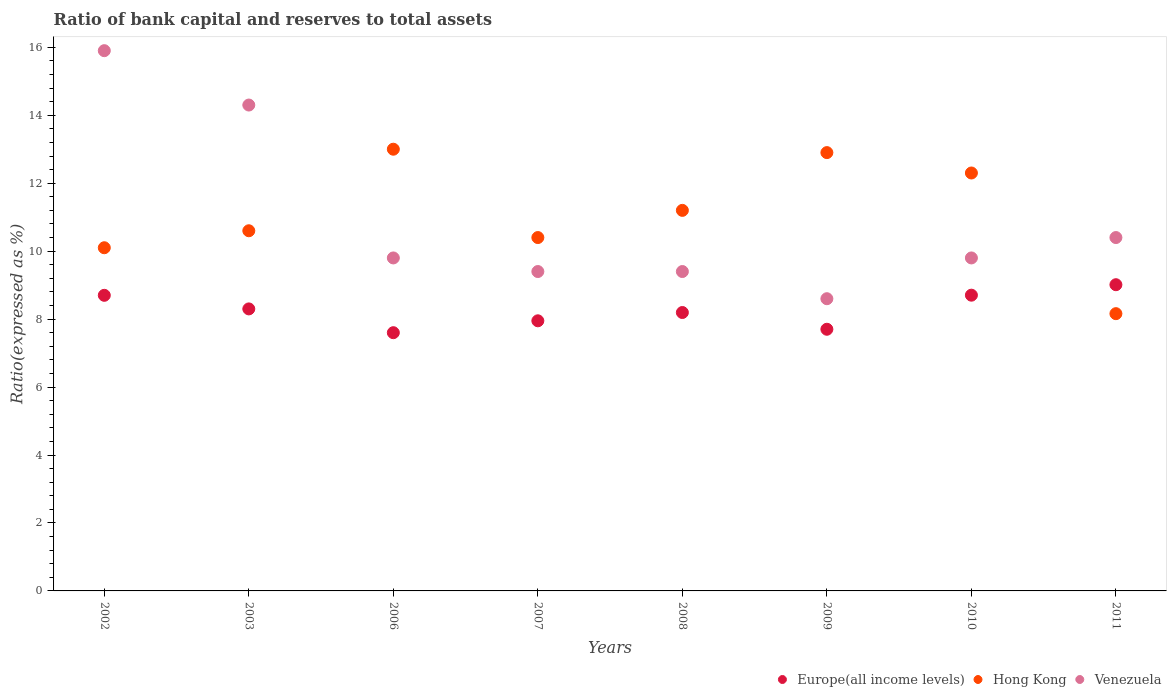What is the ratio of bank capital and reserves to total assets in Hong Kong in 2011?
Keep it short and to the point. 8.16. Across all years, what is the maximum ratio of bank capital and reserves to total assets in Venezuela?
Ensure brevity in your answer.  15.9. Across all years, what is the minimum ratio of bank capital and reserves to total assets in Venezuela?
Your answer should be compact. 8.6. In which year was the ratio of bank capital and reserves to total assets in Hong Kong maximum?
Your answer should be compact. 2006. What is the total ratio of bank capital and reserves to total assets in Venezuela in the graph?
Make the answer very short. 87.6. What is the difference between the ratio of bank capital and reserves to total assets in Europe(all income levels) in 2006 and that in 2008?
Offer a terse response. -0.59. What is the difference between the ratio of bank capital and reserves to total assets in Hong Kong in 2010 and the ratio of bank capital and reserves to total assets in Europe(all income levels) in 2009?
Provide a succinct answer. 4.6. What is the average ratio of bank capital and reserves to total assets in Venezuela per year?
Your answer should be compact. 10.95. In the year 2011, what is the difference between the ratio of bank capital and reserves to total assets in Hong Kong and ratio of bank capital and reserves to total assets in Venezuela?
Make the answer very short. -2.24. In how many years, is the ratio of bank capital and reserves to total assets in Europe(all income levels) greater than 8 %?
Offer a very short reply. 5. What is the ratio of the ratio of bank capital and reserves to total assets in Europe(all income levels) in 2007 to that in 2011?
Your response must be concise. 0.88. Is the ratio of bank capital and reserves to total assets in Venezuela in 2009 less than that in 2010?
Provide a succinct answer. Yes. What is the difference between the highest and the second highest ratio of bank capital and reserves to total assets in Hong Kong?
Offer a very short reply. 0.1. What is the difference between the highest and the lowest ratio of bank capital and reserves to total assets in Hong Kong?
Your answer should be compact. 4.84. In how many years, is the ratio of bank capital and reserves to total assets in Europe(all income levels) greater than the average ratio of bank capital and reserves to total assets in Europe(all income levels) taken over all years?
Your answer should be very brief. 4. Is the sum of the ratio of bank capital and reserves to total assets in Venezuela in 2002 and 2006 greater than the maximum ratio of bank capital and reserves to total assets in Europe(all income levels) across all years?
Provide a succinct answer. Yes. Is it the case that in every year, the sum of the ratio of bank capital and reserves to total assets in Europe(all income levels) and ratio of bank capital and reserves to total assets in Venezuela  is greater than the ratio of bank capital and reserves to total assets in Hong Kong?
Give a very brief answer. Yes. Does the ratio of bank capital and reserves to total assets in Venezuela monotonically increase over the years?
Your response must be concise. No. Is the ratio of bank capital and reserves to total assets in Hong Kong strictly greater than the ratio of bank capital and reserves to total assets in Europe(all income levels) over the years?
Provide a succinct answer. No. Is the ratio of bank capital and reserves to total assets in Europe(all income levels) strictly less than the ratio of bank capital and reserves to total assets in Venezuela over the years?
Make the answer very short. Yes. How many dotlines are there?
Make the answer very short. 3. Does the graph contain any zero values?
Keep it short and to the point. No. How many legend labels are there?
Offer a terse response. 3. How are the legend labels stacked?
Your answer should be very brief. Horizontal. What is the title of the graph?
Give a very brief answer. Ratio of bank capital and reserves to total assets. Does "Czech Republic" appear as one of the legend labels in the graph?
Offer a very short reply. No. What is the label or title of the X-axis?
Keep it short and to the point. Years. What is the label or title of the Y-axis?
Ensure brevity in your answer.  Ratio(expressed as %). What is the Ratio(expressed as %) in Europe(all income levels) in 2002?
Keep it short and to the point. 8.7. What is the Ratio(expressed as %) of Hong Kong in 2002?
Keep it short and to the point. 10.1. What is the Ratio(expressed as %) in Europe(all income levels) in 2003?
Ensure brevity in your answer.  8.3. What is the Ratio(expressed as %) of Venezuela in 2003?
Make the answer very short. 14.3. What is the Ratio(expressed as %) in Europe(all income levels) in 2006?
Your answer should be compact. 7.6. What is the Ratio(expressed as %) in Venezuela in 2006?
Provide a succinct answer. 9.8. What is the Ratio(expressed as %) of Europe(all income levels) in 2007?
Offer a terse response. 7.95. What is the Ratio(expressed as %) in Venezuela in 2007?
Your answer should be compact. 9.4. What is the Ratio(expressed as %) in Europe(all income levels) in 2008?
Make the answer very short. 8.19. What is the Ratio(expressed as %) of Venezuela in 2008?
Give a very brief answer. 9.4. What is the Ratio(expressed as %) of Europe(all income levels) in 2009?
Your answer should be compact. 7.7. What is the Ratio(expressed as %) in Hong Kong in 2009?
Make the answer very short. 12.9. What is the Ratio(expressed as %) in Venezuela in 2009?
Ensure brevity in your answer.  8.6. What is the Ratio(expressed as %) of Europe(all income levels) in 2010?
Your answer should be compact. 8.7. What is the Ratio(expressed as %) in Europe(all income levels) in 2011?
Provide a short and direct response. 9.01. What is the Ratio(expressed as %) of Hong Kong in 2011?
Offer a very short reply. 8.16. Across all years, what is the maximum Ratio(expressed as %) in Europe(all income levels)?
Provide a succinct answer. 9.01. Across all years, what is the minimum Ratio(expressed as %) in Europe(all income levels)?
Provide a short and direct response. 7.6. Across all years, what is the minimum Ratio(expressed as %) in Hong Kong?
Provide a short and direct response. 8.16. What is the total Ratio(expressed as %) in Europe(all income levels) in the graph?
Provide a short and direct response. 66.16. What is the total Ratio(expressed as %) of Hong Kong in the graph?
Ensure brevity in your answer.  88.66. What is the total Ratio(expressed as %) in Venezuela in the graph?
Provide a succinct answer. 87.6. What is the difference between the Ratio(expressed as %) of Europe(all income levels) in 2002 and that in 2003?
Provide a succinct answer. 0.4. What is the difference between the Ratio(expressed as %) in Hong Kong in 2002 and that in 2003?
Give a very brief answer. -0.5. What is the difference between the Ratio(expressed as %) in Venezuela in 2002 and that in 2006?
Keep it short and to the point. 6.1. What is the difference between the Ratio(expressed as %) of Europe(all income levels) in 2002 and that in 2008?
Make the answer very short. 0.51. What is the difference between the Ratio(expressed as %) in Venezuela in 2002 and that in 2008?
Provide a short and direct response. 6.5. What is the difference between the Ratio(expressed as %) in Venezuela in 2002 and that in 2009?
Keep it short and to the point. 7.3. What is the difference between the Ratio(expressed as %) in Europe(all income levels) in 2002 and that in 2010?
Offer a very short reply. -0. What is the difference between the Ratio(expressed as %) of Hong Kong in 2002 and that in 2010?
Your response must be concise. -2.2. What is the difference between the Ratio(expressed as %) of Europe(all income levels) in 2002 and that in 2011?
Provide a short and direct response. -0.31. What is the difference between the Ratio(expressed as %) in Hong Kong in 2002 and that in 2011?
Offer a very short reply. 1.94. What is the difference between the Ratio(expressed as %) in Venezuela in 2002 and that in 2011?
Keep it short and to the point. 5.5. What is the difference between the Ratio(expressed as %) of Europe(all income levels) in 2003 and that in 2006?
Keep it short and to the point. 0.7. What is the difference between the Ratio(expressed as %) of Hong Kong in 2003 and that in 2006?
Make the answer very short. -2.4. What is the difference between the Ratio(expressed as %) in Europe(all income levels) in 2003 and that in 2007?
Offer a terse response. 0.35. What is the difference between the Ratio(expressed as %) in Venezuela in 2003 and that in 2007?
Your answer should be very brief. 4.9. What is the difference between the Ratio(expressed as %) in Europe(all income levels) in 2003 and that in 2008?
Your answer should be compact. 0.11. What is the difference between the Ratio(expressed as %) in Venezuela in 2003 and that in 2008?
Offer a terse response. 4.9. What is the difference between the Ratio(expressed as %) of Europe(all income levels) in 2003 and that in 2009?
Your answer should be very brief. 0.6. What is the difference between the Ratio(expressed as %) of Europe(all income levels) in 2003 and that in 2010?
Offer a terse response. -0.4. What is the difference between the Ratio(expressed as %) in Europe(all income levels) in 2003 and that in 2011?
Keep it short and to the point. -0.71. What is the difference between the Ratio(expressed as %) in Hong Kong in 2003 and that in 2011?
Your response must be concise. 2.44. What is the difference between the Ratio(expressed as %) of Europe(all income levels) in 2006 and that in 2007?
Keep it short and to the point. -0.35. What is the difference between the Ratio(expressed as %) in Hong Kong in 2006 and that in 2007?
Give a very brief answer. 2.6. What is the difference between the Ratio(expressed as %) in Venezuela in 2006 and that in 2007?
Ensure brevity in your answer.  0.4. What is the difference between the Ratio(expressed as %) of Europe(all income levels) in 2006 and that in 2008?
Give a very brief answer. -0.59. What is the difference between the Ratio(expressed as %) in Hong Kong in 2006 and that in 2008?
Provide a short and direct response. 1.8. What is the difference between the Ratio(expressed as %) of Europe(all income levels) in 2006 and that in 2009?
Make the answer very short. -0.1. What is the difference between the Ratio(expressed as %) of Hong Kong in 2006 and that in 2009?
Offer a very short reply. 0.1. What is the difference between the Ratio(expressed as %) of Europe(all income levels) in 2006 and that in 2010?
Give a very brief answer. -1.1. What is the difference between the Ratio(expressed as %) in Europe(all income levels) in 2006 and that in 2011?
Your answer should be very brief. -1.41. What is the difference between the Ratio(expressed as %) of Hong Kong in 2006 and that in 2011?
Keep it short and to the point. 4.84. What is the difference between the Ratio(expressed as %) in Venezuela in 2006 and that in 2011?
Your answer should be very brief. -0.6. What is the difference between the Ratio(expressed as %) in Europe(all income levels) in 2007 and that in 2008?
Your answer should be very brief. -0.24. What is the difference between the Ratio(expressed as %) in Hong Kong in 2007 and that in 2008?
Offer a terse response. -0.8. What is the difference between the Ratio(expressed as %) in Europe(all income levels) in 2007 and that in 2009?
Give a very brief answer. 0.25. What is the difference between the Ratio(expressed as %) in Hong Kong in 2007 and that in 2009?
Keep it short and to the point. -2.5. What is the difference between the Ratio(expressed as %) of Venezuela in 2007 and that in 2009?
Make the answer very short. 0.8. What is the difference between the Ratio(expressed as %) of Europe(all income levels) in 2007 and that in 2010?
Give a very brief answer. -0.75. What is the difference between the Ratio(expressed as %) in Venezuela in 2007 and that in 2010?
Make the answer very short. -0.4. What is the difference between the Ratio(expressed as %) of Europe(all income levels) in 2007 and that in 2011?
Your answer should be very brief. -1.06. What is the difference between the Ratio(expressed as %) of Hong Kong in 2007 and that in 2011?
Provide a succinct answer. 2.24. What is the difference between the Ratio(expressed as %) in Europe(all income levels) in 2008 and that in 2009?
Give a very brief answer. 0.49. What is the difference between the Ratio(expressed as %) in Hong Kong in 2008 and that in 2009?
Make the answer very short. -1.7. What is the difference between the Ratio(expressed as %) of Europe(all income levels) in 2008 and that in 2010?
Keep it short and to the point. -0.51. What is the difference between the Ratio(expressed as %) of Hong Kong in 2008 and that in 2010?
Provide a succinct answer. -1.1. What is the difference between the Ratio(expressed as %) of Europe(all income levels) in 2008 and that in 2011?
Provide a short and direct response. -0.82. What is the difference between the Ratio(expressed as %) in Hong Kong in 2008 and that in 2011?
Provide a short and direct response. 3.04. What is the difference between the Ratio(expressed as %) of Venezuela in 2008 and that in 2011?
Your answer should be very brief. -1. What is the difference between the Ratio(expressed as %) of Europe(all income levels) in 2009 and that in 2010?
Give a very brief answer. -1. What is the difference between the Ratio(expressed as %) of Venezuela in 2009 and that in 2010?
Your answer should be very brief. -1.2. What is the difference between the Ratio(expressed as %) of Europe(all income levels) in 2009 and that in 2011?
Make the answer very short. -1.31. What is the difference between the Ratio(expressed as %) in Hong Kong in 2009 and that in 2011?
Keep it short and to the point. 4.74. What is the difference between the Ratio(expressed as %) of Europe(all income levels) in 2010 and that in 2011?
Keep it short and to the point. -0.31. What is the difference between the Ratio(expressed as %) of Hong Kong in 2010 and that in 2011?
Provide a succinct answer. 4.14. What is the difference between the Ratio(expressed as %) in Europe(all income levels) in 2002 and the Ratio(expressed as %) in Venezuela in 2003?
Keep it short and to the point. -5.6. What is the difference between the Ratio(expressed as %) in Hong Kong in 2002 and the Ratio(expressed as %) in Venezuela in 2003?
Provide a short and direct response. -4.2. What is the difference between the Ratio(expressed as %) in Europe(all income levels) in 2002 and the Ratio(expressed as %) in Venezuela in 2006?
Offer a very short reply. -1.1. What is the difference between the Ratio(expressed as %) in Hong Kong in 2002 and the Ratio(expressed as %) in Venezuela in 2006?
Your response must be concise. 0.3. What is the difference between the Ratio(expressed as %) in Europe(all income levels) in 2002 and the Ratio(expressed as %) in Venezuela in 2007?
Your response must be concise. -0.7. What is the difference between the Ratio(expressed as %) of Europe(all income levels) in 2002 and the Ratio(expressed as %) of Venezuela in 2008?
Your answer should be compact. -0.7. What is the difference between the Ratio(expressed as %) of Hong Kong in 2002 and the Ratio(expressed as %) of Venezuela in 2008?
Provide a short and direct response. 0.7. What is the difference between the Ratio(expressed as %) of Hong Kong in 2002 and the Ratio(expressed as %) of Venezuela in 2009?
Your answer should be very brief. 1.5. What is the difference between the Ratio(expressed as %) in Europe(all income levels) in 2002 and the Ratio(expressed as %) in Venezuela in 2010?
Offer a very short reply. -1.1. What is the difference between the Ratio(expressed as %) of Europe(all income levels) in 2002 and the Ratio(expressed as %) of Hong Kong in 2011?
Provide a short and direct response. 0.54. What is the difference between the Ratio(expressed as %) in Europe(all income levels) in 2003 and the Ratio(expressed as %) in Hong Kong in 2006?
Provide a succinct answer. -4.7. What is the difference between the Ratio(expressed as %) in Hong Kong in 2003 and the Ratio(expressed as %) in Venezuela in 2006?
Your answer should be compact. 0.8. What is the difference between the Ratio(expressed as %) of Europe(all income levels) in 2003 and the Ratio(expressed as %) of Venezuela in 2008?
Make the answer very short. -1.1. What is the difference between the Ratio(expressed as %) in Hong Kong in 2003 and the Ratio(expressed as %) in Venezuela in 2008?
Provide a short and direct response. 1.2. What is the difference between the Ratio(expressed as %) of Europe(all income levels) in 2003 and the Ratio(expressed as %) of Hong Kong in 2009?
Your answer should be very brief. -4.6. What is the difference between the Ratio(expressed as %) in Europe(all income levels) in 2003 and the Ratio(expressed as %) in Venezuela in 2009?
Your answer should be very brief. -0.3. What is the difference between the Ratio(expressed as %) of Europe(all income levels) in 2003 and the Ratio(expressed as %) of Hong Kong in 2010?
Your answer should be very brief. -4. What is the difference between the Ratio(expressed as %) in Europe(all income levels) in 2003 and the Ratio(expressed as %) in Venezuela in 2010?
Ensure brevity in your answer.  -1.5. What is the difference between the Ratio(expressed as %) in Europe(all income levels) in 2003 and the Ratio(expressed as %) in Hong Kong in 2011?
Provide a succinct answer. 0.14. What is the difference between the Ratio(expressed as %) of Europe(all income levels) in 2006 and the Ratio(expressed as %) of Hong Kong in 2007?
Your answer should be compact. -2.8. What is the difference between the Ratio(expressed as %) in Hong Kong in 2006 and the Ratio(expressed as %) in Venezuela in 2007?
Offer a very short reply. 3.6. What is the difference between the Ratio(expressed as %) of Europe(all income levels) in 2006 and the Ratio(expressed as %) of Hong Kong in 2009?
Keep it short and to the point. -5.3. What is the difference between the Ratio(expressed as %) in Europe(all income levels) in 2006 and the Ratio(expressed as %) in Venezuela in 2009?
Make the answer very short. -1. What is the difference between the Ratio(expressed as %) of Hong Kong in 2006 and the Ratio(expressed as %) of Venezuela in 2009?
Ensure brevity in your answer.  4.4. What is the difference between the Ratio(expressed as %) of Europe(all income levels) in 2006 and the Ratio(expressed as %) of Venezuela in 2010?
Provide a succinct answer. -2.2. What is the difference between the Ratio(expressed as %) of Hong Kong in 2006 and the Ratio(expressed as %) of Venezuela in 2010?
Your answer should be very brief. 3.2. What is the difference between the Ratio(expressed as %) in Europe(all income levels) in 2006 and the Ratio(expressed as %) in Hong Kong in 2011?
Provide a short and direct response. -0.56. What is the difference between the Ratio(expressed as %) of Europe(all income levels) in 2006 and the Ratio(expressed as %) of Venezuela in 2011?
Provide a succinct answer. -2.8. What is the difference between the Ratio(expressed as %) in Hong Kong in 2006 and the Ratio(expressed as %) in Venezuela in 2011?
Make the answer very short. 2.6. What is the difference between the Ratio(expressed as %) of Europe(all income levels) in 2007 and the Ratio(expressed as %) of Hong Kong in 2008?
Provide a succinct answer. -3.25. What is the difference between the Ratio(expressed as %) of Europe(all income levels) in 2007 and the Ratio(expressed as %) of Venezuela in 2008?
Make the answer very short. -1.45. What is the difference between the Ratio(expressed as %) of Europe(all income levels) in 2007 and the Ratio(expressed as %) of Hong Kong in 2009?
Offer a very short reply. -4.95. What is the difference between the Ratio(expressed as %) of Europe(all income levels) in 2007 and the Ratio(expressed as %) of Venezuela in 2009?
Offer a terse response. -0.65. What is the difference between the Ratio(expressed as %) of Europe(all income levels) in 2007 and the Ratio(expressed as %) of Hong Kong in 2010?
Provide a short and direct response. -4.35. What is the difference between the Ratio(expressed as %) of Europe(all income levels) in 2007 and the Ratio(expressed as %) of Venezuela in 2010?
Offer a terse response. -1.85. What is the difference between the Ratio(expressed as %) of Europe(all income levels) in 2007 and the Ratio(expressed as %) of Hong Kong in 2011?
Make the answer very short. -0.21. What is the difference between the Ratio(expressed as %) in Europe(all income levels) in 2007 and the Ratio(expressed as %) in Venezuela in 2011?
Your response must be concise. -2.45. What is the difference between the Ratio(expressed as %) in Hong Kong in 2007 and the Ratio(expressed as %) in Venezuela in 2011?
Provide a short and direct response. 0. What is the difference between the Ratio(expressed as %) in Europe(all income levels) in 2008 and the Ratio(expressed as %) in Hong Kong in 2009?
Your answer should be compact. -4.71. What is the difference between the Ratio(expressed as %) in Europe(all income levels) in 2008 and the Ratio(expressed as %) in Venezuela in 2009?
Provide a succinct answer. -0.41. What is the difference between the Ratio(expressed as %) of Hong Kong in 2008 and the Ratio(expressed as %) of Venezuela in 2009?
Provide a short and direct response. 2.6. What is the difference between the Ratio(expressed as %) in Europe(all income levels) in 2008 and the Ratio(expressed as %) in Hong Kong in 2010?
Your answer should be compact. -4.11. What is the difference between the Ratio(expressed as %) of Europe(all income levels) in 2008 and the Ratio(expressed as %) of Venezuela in 2010?
Offer a very short reply. -1.61. What is the difference between the Ratio(expressed as %) in Hong Kong in 2008 and the Ratio(expressed as %) in Venezuela in 2010?
Ensure brevity in your answer.  1.4. What is the difference between the Ratio(expressed as %) of Europe(all income levels) in 2008 and the Ratio(expressed as %) of Hong Kong in 2011?
Provide a succinct answer. 0.03. What is the difference between the Ratio(expressed as %) in Europe(all income levels) in 2008 and the Ratio(expressed as %) in Venezuela in 2011?
Provide a succinct answer. -2.21. What is the difference between the Ratio(expressed as %) in Hong Kong in 2008 and the Ratio(expressed as %) in Venezuela in 2011?
Offer a very short reply. 0.8. What is the difference between the Ratio(expressed as %) in Europe(all income levels) in 2009 and the Ratio(expressed as %) in Hong Kong in 2010?
Make the answer very short. -4.6. What is the difference between the Ratio(expressed as %) of Europe(all income levels) in 2009 and the Ratio(expressed as %) of Venezuela in 2010?
Give a very brief answer. -2.1. What is the difference between the Ratio(expressed as %) of Europe(all income levels) in 2009 and the Ratio(expressed as %) of Hong Kong in 2011?
Your answer should be compact. -0.46. What is the difference between the Ratio(expressed as %) in Europe(all income levels) in 2009 and the Ratio(expressed as %) in Venezuela in 2011?
Ensure brevity in your answer.  -2.7. What is the difference between the Ratio(expressed as %) in Europe(all income levels) in 2010 and the Ratio(expressed as %) in Hong Kong in 2011?
Your answer should be very brief. 0.54. What is the difference between the Ratio(expressed as %) in Europe(all income levels) in 2010 and the Ratio(expressed as %) in Venezuela in 2011?
Offer a terse response. -1.7. What is the difference between the Ratio(expressed as %) in Hong Kong in 2010 and the Ratio(expressed as %) in Venezuela in 2011?
Your answer should be very brief. 1.9. What is the average Ratio(expressed as %) in Europe(all income levels) per year?
Your response must be concise. 8.27. What is the average Ratio(expressed as %) in Hong Kong per year?
Your answer should be compact. 11.08. What is the average Ratio(expressed as %) in Venezuela per year?
Offer a terse response. 10.95. In the year 2002, what is the difference between the Ratio(expressed as %) in Europe(all income levels) and Ratio(expressed as %) in Venezuela?
Your answer should be compact. -7.2. In the year 2003, what is the difference between the Ratio(expressed as %) in Europe(all income levels) and Ratio(expressed as %) in Venezuela?
Offer a terse response. -6. In the year 2006, what is the difference between the Ratio(expressed as %) of Europe(all income levels) and Ratio(expressed as %) of Venezuela?
Your answer should be very brief. -2.2. In the year 2006, what is the difference between the Ratio(expressed as %) of Hong Kong and Ratio(expressed as %) of Venezuela?
Offer a very short reply. 3.2. In the year 2007, what is the difference between the Ratio(expressed as %) of Europe(all income levels) and Ratio(expressed as %) of Hong Kong?
Provide a succinct answer. -2.45. In the year 2007, what is the difference between the Ratio(expressed as %) of Europe(all income levels) and Ratio(expressed as %) of Venezuela?
Make the answer very short. -1.45. In the year 2007, what is the difference between the Ratio(expressed as %) in Hong Kong and Ratio(expressed as %) in Venezuela?
Provide a succinct answer. 1. In the year 2008, what is the difference between the Ratio(expressed as %) of Europe(all income levels) and Ratio(expressed as %) of Hong Kong?
Your answer should be compact. -3.01. In the year 2008, what is the difference between the Ratio(expressed as %) of Europe(all income levels) and Ratio(expressed as %) of Venezuela?
Keep it short and to the point. -1.21. In the year 2009, what is the difference between the Ratio(expressed as %) of Europe(all income levels) and Ratio(expressed as %) of Hong Kong?
Your answer should be compact. -5.2. In the year 2009, what is the difference between the Ratio(expressed as %) in Europe(all income levels) and Ratio(expressed as %) in Venezuela?
Your response must be concise. -0.9. In the year 2009, what is the difference between the Ratio(expressed as %) in Hong Kong and Ratio(expressed as %) in Venezuela?
Make the answer very short. 4.3. In the year 2010, what is the difference between the Ratio(expressed as %) in Europe(all income levels) and Ratio(expressed as %) in Hong Kong?
Provide a short and direct response. -3.6. In the year 2010, what is the difference between the Ratio(expressed as %) in Europe(all income levels) and Ratio(expressed as %) in Venezuela?
Give a very brief answer. -1.1. In the year 2011, what is the difference between the Ratio(expressed as %) of Europe(all income levels) and Ratio(expressed as %) of Hong Kong?
Offer a terse response. 0.85. In the year 2011, what is the difference between the Ratio(expressed as %) of Europe(all income levels) and Ratio(expressed as %) of Venezuela?
Give a very brief answer. -1.39. In the year 2011, what is the difference between the Ratio(expressed as %) in Hong Kong and Ratio(expressed as %) in Venezuela?
Provide a short and direct response. -2.24. What is the ratio of the Ratio(expressed as %) of Europe(all income levels) in 2002 to that in 2003?
Provide a succinct answer. 1.05. What is the ratio of the Ratio(expressed as %) in Hong Kong in 2002 to that in 2003?
Ensure brevity in your answer.  0.95. What is the ratio of the Ratio(expressed as %) in Venezuela in 2002 to that in 2003?
Your answer should be very brief. 1.11. What is the ratio of the Ratio(expressed as %) in Europe(all income levels) in 2002 to that in 2006?
Provide a short and direct response. 1.14. What is the ratio of the Ratio(expressed as %) in Hong Kong in 2002 to that in 2006?
Provide a succinct answer. 0.78. What is the ratio of the Ratio(expressed as %) of Venezuela in 2002 to that in 2006?
Give a very brief answer. 1.62. What is the ratio of the Ratio(expressed as %) in Europe(all income levels) in 2002 to that in 2007?
Ensure brevity in your answer.  1.09. What is the ratio of the Ratio(expressed as %) in Hong Kong in 2002 to that in 2007?
Ensure brevity in your answer.  0.97. What is the ratio of the Ratio(expressed as %) of Venezuela in 2002 to that in 2007?
Keep it short and to the point. 1.69. What is the ratio of the Ratio(expressed as %) of Europe(all income levels) in 2002 to that in 2008?
Your answer should be very brief. 1.06. What is the ratio of the Ratio(expressed as %) in Hong Kong in 2002 to that in 2008?
Ensure brevity in your answer.  0.9. What is the ratio of the Ratio(expressed as %) of Venezuela in 2002 to that in 2008?
Your response must be concise. 1.69. What is the ratio of the Ratio(expressed as %) of Europe(all income levels) in 2002 to that in 2009?
Ensure brevity in your answer.  1.13. What is the ratio of the Ratio(expressed as %) in Hong Kong in 2002 to that in 2009?
Your answer should be very brief. 0.78. What is the ratio of the Ratio(expressed as %) of Venezuela in 2002 to that in 2009?
Keep it short and to the point. 1.85. What is the ratio of the Ratio(expressed as %) in Hong Kong in 2002 to that in 2010?
Offer a very short reply. 0.82. What is the ratio of the Ratio(expressed as %) of Venezuela in 2002 to that in 2010?
Provide a succinct answer. 1.62. What is the ratio of the Ratio(expressed as %) of Europe(all income levels) in 2002 to that in 2011?
Make the answer very short. 0.97. What is the ratio of the Ratio(expressed as %) of Hong Kong in 2002 to that in 2011?
Offer a terse response. 1.24. What is the ratio of the Ratio(expressed as %) in Venezuela in 2002 to that in 2011?
Provide a short and direct response. 1.53. What is the ratio of the Ratio(expressed as %) in Europe(all income levels) in 2003 to that in 2006?
Your answer should be very brief. 1.09. What is the ratio of the Ratio(expressed as %) of Hong Kong in 2003 to that in 2006?
Ensure brevity in your answer.  0.82. What is the ratio of the Ratio(expressed as %) of Venezuela in 2003 to that in 2006?
Provide a succinct answer. 1.46. What is the ratio of the Ratio(expressed as %) in Europe(all income levels) in 2003 to that in 2007?
Offer a terse response. 1.04. What is the ratio of the Ratio(expressed as %) of Hong Kong in 2003 to that in 2007?
Make the answer very short. 1.02. What is the ratio of the Ratio(expressed as %) in Venezuela in 2003 to that in 2007?
Offer a terse response. 1.52. What is the ratio of the Ratio(expressed as %) in Europe(all income levels) in 2003 to that in 2008?
Your answer should be very brief. 1.01. What is the ratio of the Ratio(expressed as %) of Hong Kong in 2003 to that in 2008?
Ensure brevity in your answer.  0.95. What is the ratio of the Ratio(expressed as %) of Venezuela in 2003 to that in 2008?
Provide a short and direct response. 1.52. What is the ratio of the Ratio(expressed as %) in Europe(all income levels) in 2003 to that in 2009?
Make the answer very short. 1.08. What is the ratio of the Ratio(expressed as %) of Hong Kong in 2003 to that in 2009?
Your answer should be compact. 0.82. What is the ratio of the Ratio(expressed as %) in Venezuela in 2003 to that in 2009?
Your response must be concise. 1.66. What is the ratio of the Ratio(expressed as %) in Europe(all income levels) in 2003 to that in 2010?
Your answer should be very brief. 0.95. What is the ratio of the Ratio(expressed as %) in Hong Kong in 2003 to that in 2010?
Ensure brevity in your answer.  0.86. What is the ratio of the Ratio(expressed as %) in Venezuela in 2003 to that in 2010?
Provide a short and direct response. 1.46. What is the ratio of the Ratio(expressed as %) of Europe(all income levels) in 2003 to that in 2011?
Make the answer very short. 0.92. What is the ratio of the Ratio(expressed as %) of Hong Kong in 2003 to that in 2011?
Offer a very short reply. 1.3. What is the ratio of the Ratio(expressed as %) in Venezuela in 2003 to that in 2011?
Provide a succinct answer. 1.38. What is the ratio of the Ratio(expressed as %) of Europe(all income levels) in 2006 to that in 2007?
Make the answer very short. 0.96. What is the ratio of the Ratio(expressed as %) in Hong Kong in 2006 to that in 2007?
Keep it short and to the point. 1.25. What is the ratio of the Ratio(expressed as %) of Venezuela in 2006 to that in 2007?
Your answer should be compact. 1.04. What is the ratio of the Ratio(expressed as %) of Europe(all income levels) in 2006 to that in 2008?
Your answer should be very brief. 0.93. What is the ratio of the Ratio(expressed as %) of Hong Kong in 2006 to that in 2008?
Keep it short and to the point. 1.16. What is the ratio of the Ratio(expressed as %) of Venezuela in 2006 to that in 2008?
Your response must be concise. 1.04. What is the ratio of the Ratio(expressed as %) in Europe(all income levels) in 2006 to that in 2009?
Offer a very short reply. 0.99. What is the ratio of the Ratio(expressed as %) of Hong Kong in 2006 to that in 2009?
Give a very brief answer. 1.01. What is the ratio of the Ratio(expressed as %) of Venezuela in 2006 to that in 2009?
Provide a short and direct response. 1.14. What is the ratio of the Ratio(expressed as %) in Europe(all income levels) in 2006 to that in 2010?
Make the answer very short. 0.87. What is the ratio of the Ratio(expressed as %) of Hong Kong in 2006 to that in 2010?
Ensure brevity in your answer.  1.06. What is the ratio of the Ratio(expressed as %) in Venezuela in 2006 to that in 2010?
Offer a very short reply. 1. What is the ratio of the Ratio(expressed as %) in Europe(all income levels) in 2006 to that in 2011?
Offer a very short reply. 0.84. What is the ratio of the Ratio(expressed as %) of Hong Kong in 2006 to that in 2011?
Keep it short and to the point. 1.59. What is the ratio of the Ratio(expressed as %) in Venezuela in 2006 to that in 2011?
Keep it short and to the point. 0.94. What is the ratio of the Ratio(expressed as %) of Europe(all income levels) in 2007 to that in 2008?
Make the answer very short. 0.97. What is the ratio of the Ratio(expressed as %) in Hong Kong in 2007 to that in 2008?
Ensure brevity in your answer.  0.93. What is the ratio of the Ratio(expressed as %) in Europe(all income levels) in 2007 to that in 2009?
Provide a succinct answer. 1.03. What is the ratio of the Ratio(expressed as %) of Hong Kong in 2007 to that in 2009?
Ensure brevity in your answer.  0.81. What is the ratio of the Ratio(expressed as %) of Venezuela in 2007 to that in 2009?
Give a very brief answer. 1.09. What is the ratio of the Ratio(expressed as %) in Europe(all income levels) in 2007 to that in 2010?
Your answer should be compact. 0.91. What is the ratio of the Ratio(expressed as %) of Hong Kong in 2007 to that in 2010?
Your answer should be very brief. 0.85. What is the ratio of the Ratio(expressed as %) of Venezuela in 2007 to that in 2010?
Give a very brief answer. 0.96. What is the ratio of the Ratio(expressed as %) in Europe(all income levels) in 2007 to that in 2011?
Offer a terse response. 0.88. What is the ratio of the Ratio(expressed as %) in Hong Kong in 2007 to that in 2011?
Provide a succinct answer. 1.27. What is the ratio of the Ratio(expressed as %) of Venezuela in 2007 to that in 2011?
Keep it short and to the point. 0.9. What is the ratio of the Ratio(expressed as %) of Europe(all income levels) in 2008 to that in 2009?
Give a very brief answer. 1.06. What is the ratio of the Ratio(expressed as %) in Hong Kong in 2008 to that in 2009?
Provide a short and direct response. 0.87. What is the ratio of the Ratio(expressed as %) in Venezuela in 2008 to that in 2009?
Keep it short and to the point. 1.09. What is the ratio of the Ratio(expressed as %) in Europe(all income levels) in 2008 to that in 2010?
Offer a very short reply. 0.94. What is the ratio of the Ratio(expressed as %) in Hong Kong in 2008 to that in 2010?
Your answer should be very brief. 0.91. What is the ratio of the Ratio(expressed as %) in Venezuela in 2008 to that in 2010?
Give a very brief answer. 0.96. What is the ratio of the Ratio(expressed as %) of Europe(all income levels) in 2008 to that in 2011?
Provide a succinct answer. 0.91. What is the ratio of the Ratio(expressed as %) in Hong Kong in 2008 to that in 2011?
Keep it short and to the point. 1.37. What is the ratio of the Ratio(expressed as %) in Venezuela in 2008 to that in 2011?
Make the answer very short. 0.9. What is the ratio of the Ratio(expressed as %) of Europe(all income levels) in 2009 to that in 2010?
Provide a short and direct response. 0.88. What is the ratio of the Ratio(expressed as %) of Hong Kong in 2009 to that in 2010?
Make the answer very short. 1.05. What is the ratio of the Ratio(expressed as %) in Venezuela in 2009 to that in 2010?
Offer a terse response. 0.88. What is the ratio of the Ratio(expressed as %) of Europe(all income levels) in 2009 to that in 2011?
Your answer should be compact. 0.85. What is the ratio of the Ratio(expressed as %) in Hong Kong in 2009 to that in 2011?
Your response must be concise. 1.58. What is the ratio of the Ratio(expressed as %) of Venezuela in 2009 to that in 2011?
Offer a terse response. 0.83. What is the ratio of the Ratio(expressed as %) of Europe(all income levels) in 2010 to that in 2011?
Make the answer very short. 0.97. What is the ratio of the Ratio(expressed as %) in Hong Kong in 2010 to that in 2011?
Give a very brief answer. 1.51. What is the ratio of the Ratio(expressed as %) in Venezuela in 2010 to that in 2011?
Provide a succinct answer. 0.94. What is the difference between the highest and the second highest Ratio(expressed as %) of Europe(all income levels)?
Offer a terse response. 0.31. What is the difference between the highest and the second highest Ratio(expressed as %) of Hong Kong?
Give a very brief answer. 0.1. What is the difference between the highest and the lowest Ratio(expressed as %) in Europe(all income levels)?
Make the answer very short. 1.41. What is the difference between the highest and the lowest Ratio(expressed as %) of Hong Kong?
Provide a short and direct response. 4.84. 